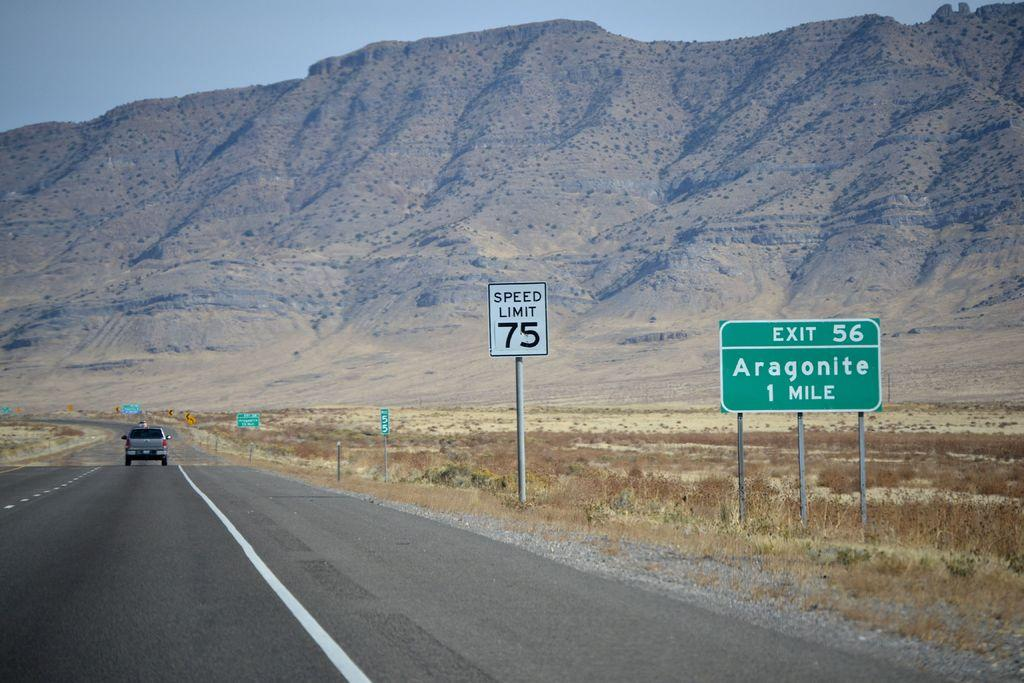Provide a one-sentence caption for the provided image. Signs on an interstate for exit 56 to Aragonite indicating it's one mile away. 